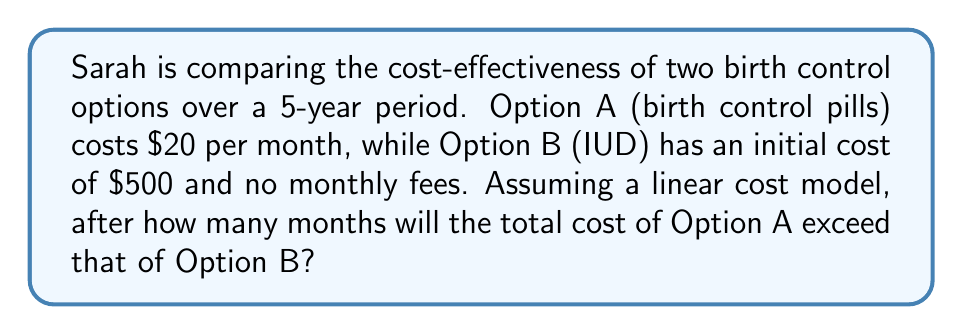Help me with this question. Let's approach this step-by-step:

1) Let $x$ be the number of months.

2) For Option A (birth control pills):
   Cost after $x$ months = $20x$

3) For Option B (IUD):
   Cost after $x$ months = $500$ (constant)

4) We want to find when Option A's cost exceeds Option B's:
   $20x > 500$

5) Solving this inequality:
   $x > \frac{500}{20}$
   $x > 25$

6) Since we're dealing with whole months, the first month where Option A's cost exceeds Option B's is the 26th month.

7) To verify:
   At 25 months: Option A costs $20 * 25 = $500$, equal to Option B
   At 26 months: Option A costs $20 * 26 = $520$, exceeding Option B's $500$

Therefore, after 26 months, the total cost of Option A will exceed that of Option B.
Answer: 26 months 